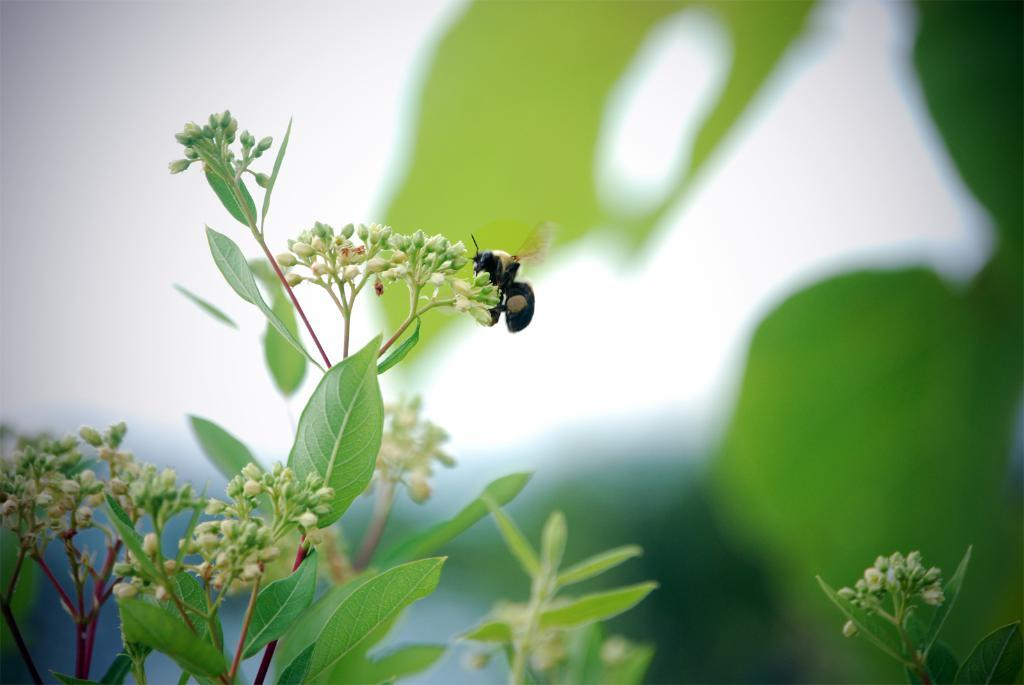What is present on the buds of the plant in the foreground of the image? There is an insect on the buds of a plant in the foreground of the image. What can be seen in the background of the image? There are plants in the background of the image. What type of home does the insect have in the image? There is no information about the insect's home in the image. 